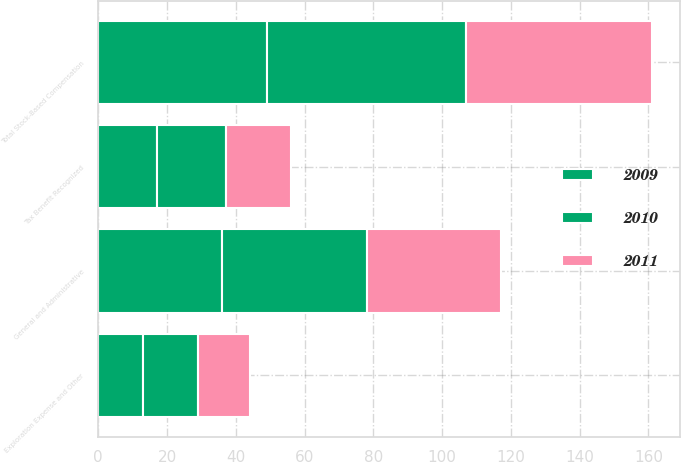<chart> <loc_0><loc_0><loc_500><loc_500><stacked_bar_chart><ecel><fcel>General and Administrative<fcel>Exploration Expense and Other<fcel>Total Stock-Based Compensation<fcel>Tax Benefit Recognized<nl><fcel>2010<fcel>42<fcel>16<fcel>58<fcel>20<nl><fcel>2011<fcel>39<fcel>15<fcel>54<fcel>19<nl><fcel>2009<fcel>36<fcel>13<fcel>49<fcel>17<nl></chart> 